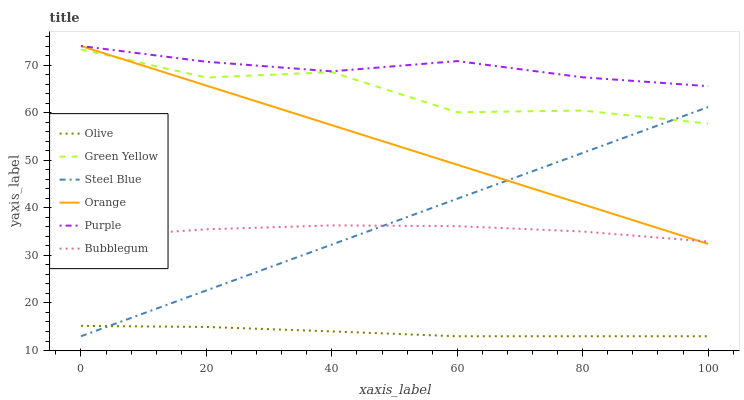Does Olive have the minimum area under the curve?
Answer yes or no. Yes. Does Purple have the maximum area under the curve?
Answer yes or no. Yes. Does Steel Blue have the minimum area under the curve?
Answer yes or no. No. Does Steel Blue have the maximum area under the curve?
Answer yes or no. No. Is Steel Blue the smoothest?
Answer yes or no. Yes. Is Green Yellow the roughest?
Answer yes or no. Yes. Is Bubblegum the smoothest?
Answer yes or no. No. Is Bubblegum the roughest?
Answer yes or no. No. Does Steel Blue have the lowest value?
Answer yes or no. Yes. Does Bubblegum have the lowest value?
Answer yes or no. No. Does Orange have the highest value?
Answer yes or no. Yes. Does Steel Blue have the highest value?
Answer yes or no. No. Is Bubblegum less than Green Yellow?
Answer yes or no. Yes. Is Purple greater than Olive?
Answer yes or no. Yes. Does Purple intersect Orange?
Answer yes or no. Yes. Is Purple less than Orange?
Answer yes or no. No. Is Purple greater than Orange?
Answer yes or no. No. Does Bubblegum intersect Green Yellow?
Answer yes or no. No. 